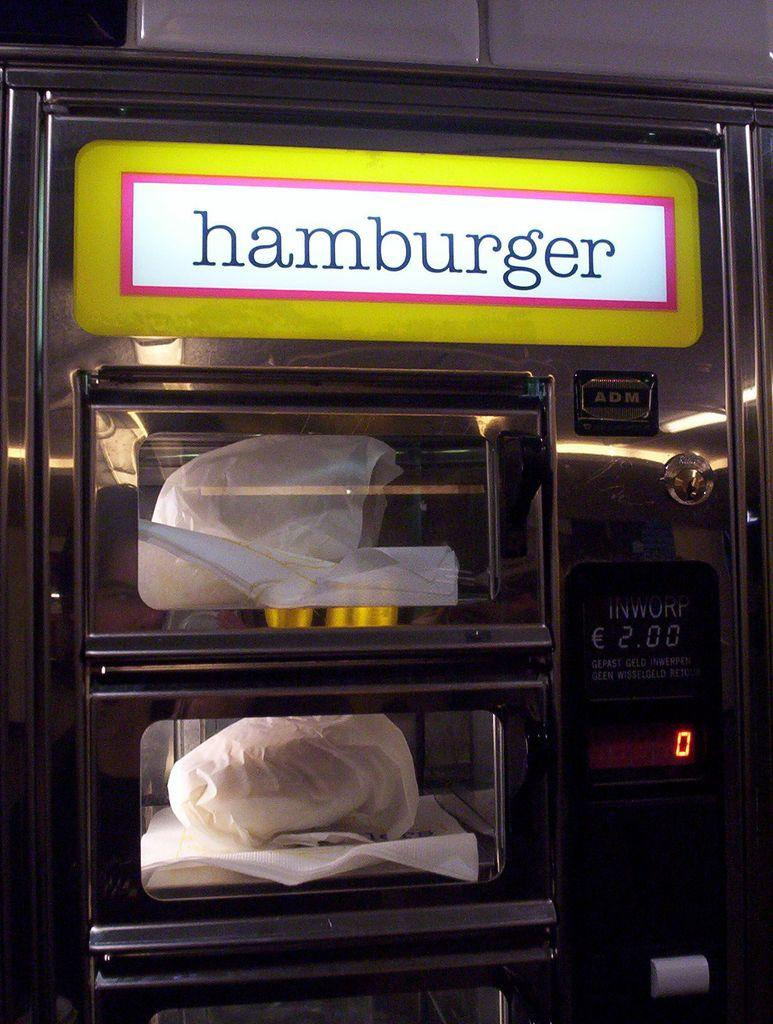<image>
Share a concise interpretation of the image provided. A hamburger vending machine costs two Euros for a burger wrapped in paper. 